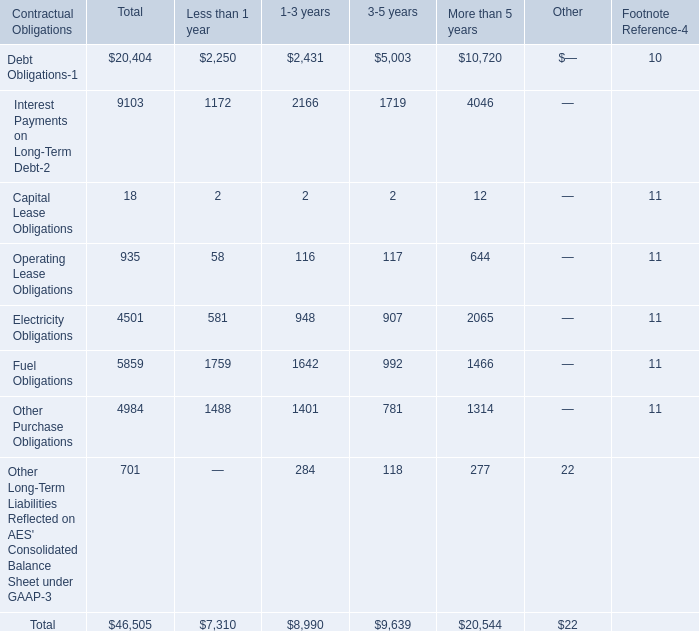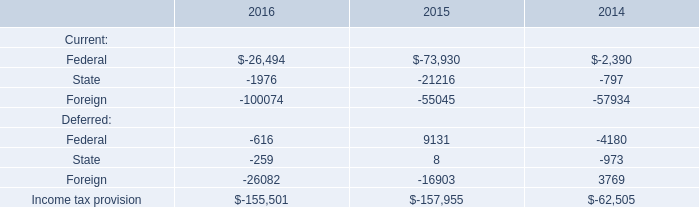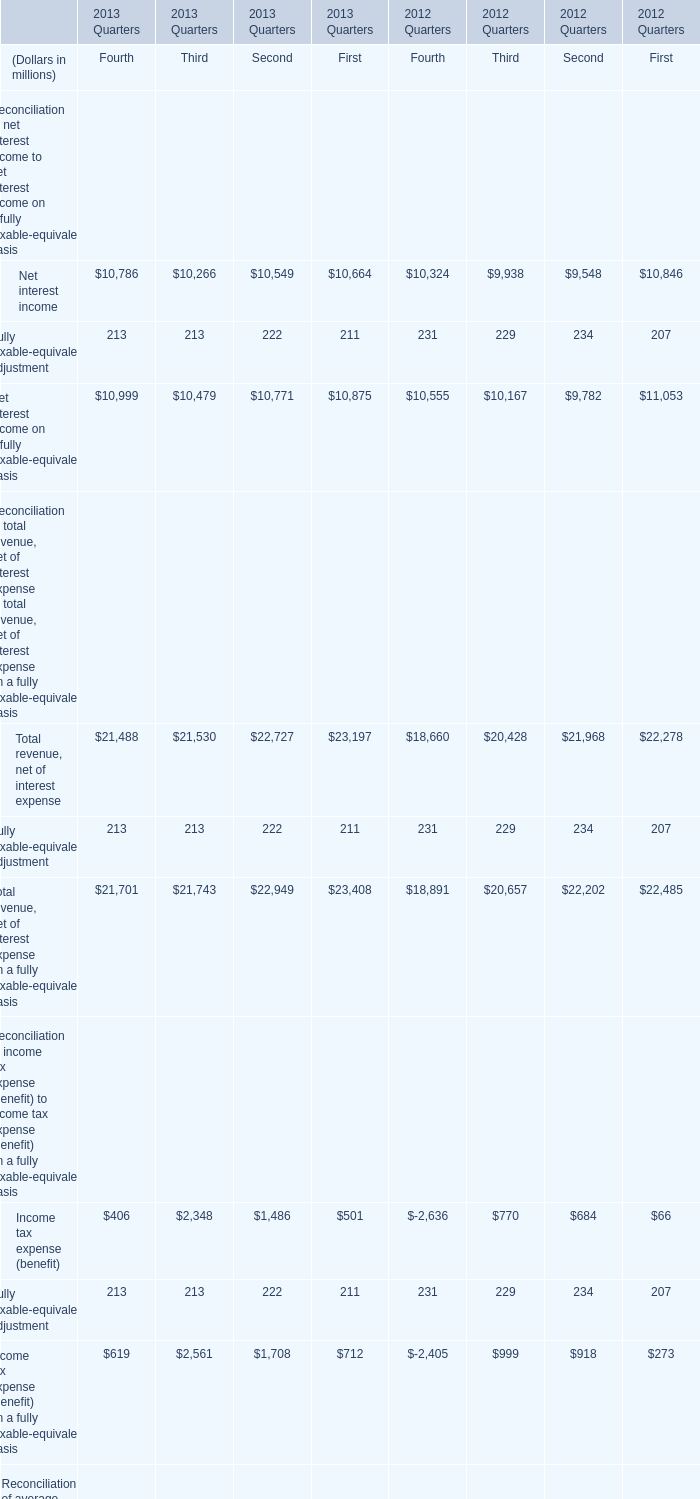what's the total amount of Net interest income of 2013 Quarters First, and Electricity Obligations of More than 5 years ? 
Computations: (10664.0 + 2065.0)
Answer: 12729.0. 